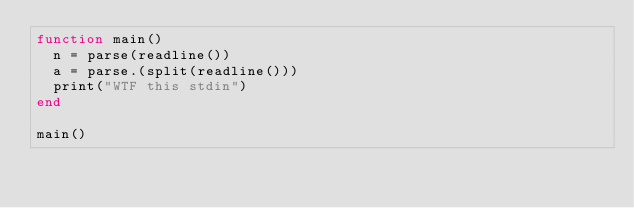Convert code to text. <code><loc_0><loc_0><loc_500><loc_500><_Julia_>function main()
  n = parse(readline())
  a = parse.(split(readline()))
  print("WTF this stdin")
end

main()</code> 